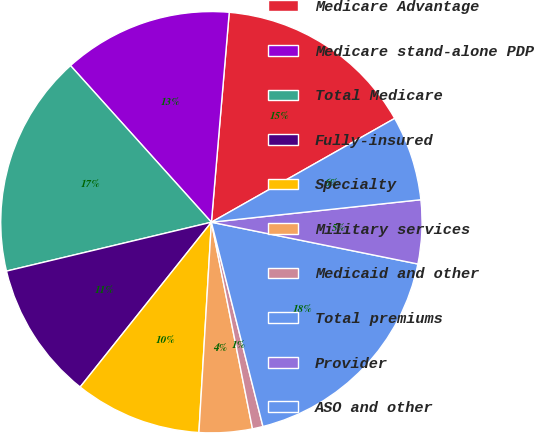<chart> <loc_0><loc_0><loc_500><loc_500><pie_chart><fcel>Medicare Advantage<fcel>Medicare stand-alone PDP<fcel>Total Medicare<fcel>Fully-insured<fcel>Specialty<fcel>Military services<fcel>Medicaid and other<fcel>Total premiums<fcel>Provider<fcel>ASO and other<nl><fcel>15.45%<fcel>13.01%<fcel>17.07%<fcel>10.57%<fcel>9.76%<fcel>4.07%<fcel>0.81%<fcel>17.89%<fcel>4.88%<fcel>6.5%<nl></chart> 